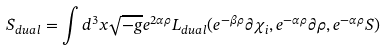<formula> <loc_0><loc_0><loc_500><loc_500>S _ { d u a l } = \int d ^ { 3 } x \sqrt { - g } e ^ { 2 \alpha \rho } L _ { d u a l } ( e ^ { - \beta \rho } \partial \chi _ { i } , e ^ { - \alpha \rho } \partial \rho , e ^ { - \alpha \rho } S )</formula> 